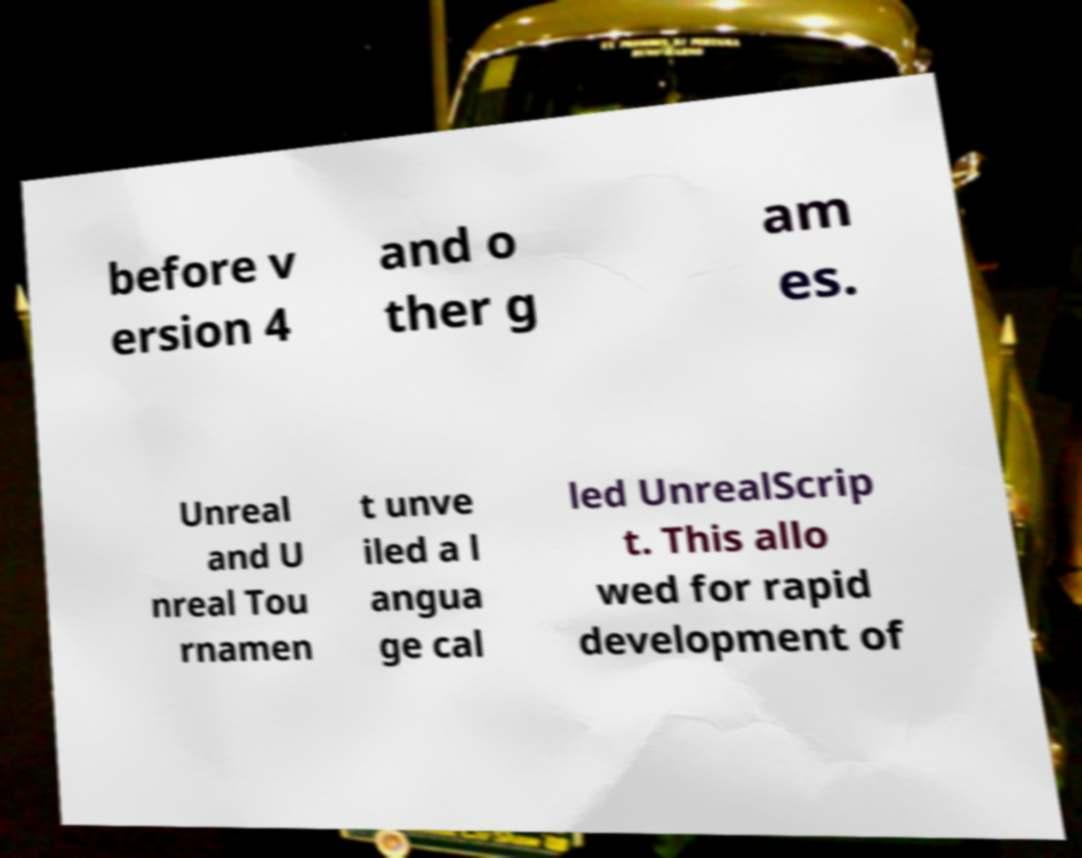Can you accurately transcribe the text from the provided image for me? before v ersion 4 and o ther g am es. Unreal and U nreal Tou rnamen t unve iled a l angua ge cal led UnrealScrip t. This allo wed for rapid development of 